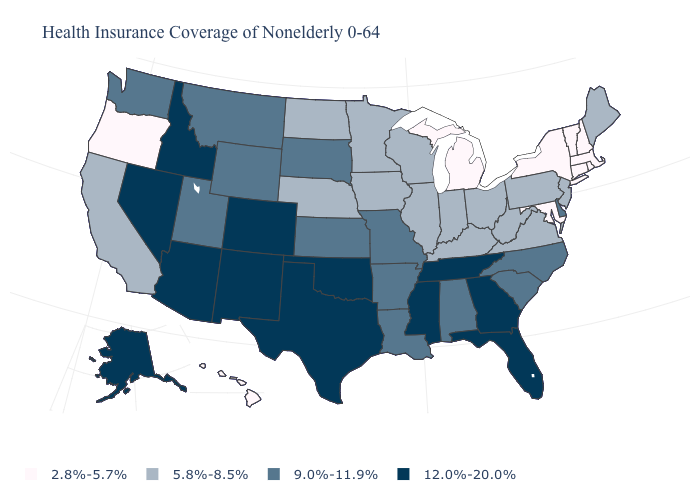Name the states that have a value in the range 5.8%-8.5%?
Quick response, please. California, Illinois, Indiana, Iowa, Kentucky, Maine, Minnesota, Nebraska, New Jersey, North Dakota, Ohio, Pennsylvania, Virginia, West Virginia, Wisconsin. What is the value of New Jersey?
Give a very brief answer. 5.8%-8.5%. Name the states that have a value in the range 5.8%-8.5%?
Answer briefly. California, Illinois, Indiana, Iowa, Kentucky, Maine, Minnesota, Nebraska, New Jersey, North Dakota, Ohio, Pennsylvania, Virginia, West Virginia, Wisconsin. What is the value of Georgia?
Short answer required. 12.0%-20.0%. Does the map have missing data?
Be succinct. No. What is the value of Nebraska?
Keep it brief. 5.8%-8.5%. Among the states that border Alabama , which have the highest value?
Be succinct. Florida, Georgia, Mississippi, Tennessee. Which states hav the highest value in the West?
Quick response, please. Alaska, Arizona, Colorado, Idaho, Nevada, New Mexico. What is the lowest value in the Northeast?
Short answer required. 2.8%-5.7%. What is the value of North Carolina?
Answer briefly. 9.0%-11.9%. What is the value of North Carolina?
Answer briefly. 9.0%-11.9%. Does Hawaii have the lowest value in the West?
Short answer required. Yes. Which states have the lowest value in the West?
Give a very brief answer. Hawaii, Oregon. Does Oregon have the lowest value in the West?
Quick response, please. Yes. Does Tennessee have the same value as New Mexico?
Quick response, please. Yes. 